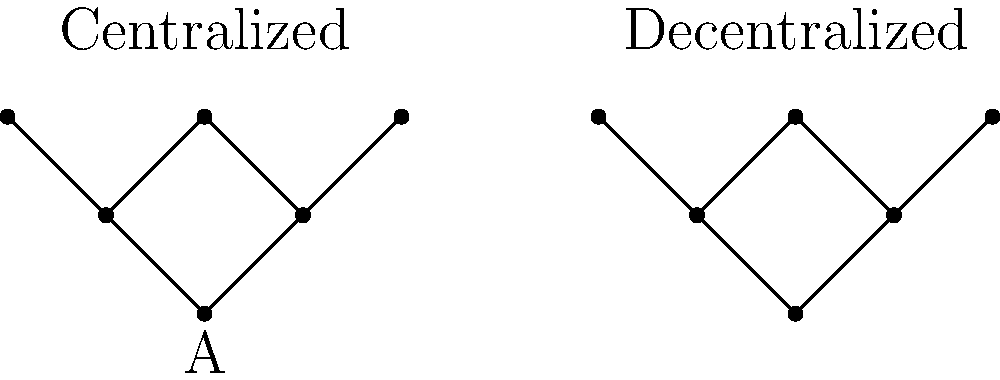Consider the centralized and decentralized network structures depicted above. How might these structures influence an organization's ability to adapt to rapidly changing environments, and what philosophical implications does this have for our understanding of organizational power dynamics? To answer this question, let's analyze the structures step-by-step:

1. Centralized Network:
   - All nodes connect to a central node (A)
   - Information flows through A
   - Decision-making is concentrated

2. Decentralized Network:
   - Nodes are interconnected without a clear center
   - Information flows through multiple pathways
   - Decision-making is distributed

3. Adaptability in Centralized Networks:
   - Pros: Quick decision-making, clear chain of command
   - Cons: Potential bottlenecks, single point of failure

4. Adaptability in Decentralized Networks:
   - Pros: Resilience, diverse perspectives, parallel processing
   - Cons: Potential for conflicting decisions, slower consensus

5. Philosophical Implications:
   - Questions the nature of power: Is centralized authority more efficient or an illusion of control?
   - Challenges the concept of organizational boundaries: Are decentralized networks more aligned with natural systems?
   - Raises ethical considerations: Does decentralization lead to more equitable power distribution?
   - Examines epistemological aspects: How does network structure influence organizational knowledge creation and dissemination?

6. Adaptability Analysis:
   - Rapidly changing environments require quick information processing and flexible responses
   - Decentralized networks may be more adaptable due to:
     a) Parallel processing of information
     b) Diverse problem-solving approaches
     c) Reduced vulnerability to single point failures

7. Power Dynamics:
   - Centralized networks reinforce traditional hierarchical power structures
   - Decentralized networks challenge conventional notions of organizational control
   - The shift towards decentralization may reflect a broader societal move towards distributed systems (e.g., blockchain, open-source)

In conclusion, decentralized networks generally offer greater adaptability in rapidly changing environments. This suggests a need to reconsider traditional management philosophies that prioritize centralized control, pointing towards more fluid, emergent forms of organization that may better reflect the complexity of modern challenges.
Answer: Decentralized networks tend to offer greater adaptability, challenging traditional notions of organizational power and control. 